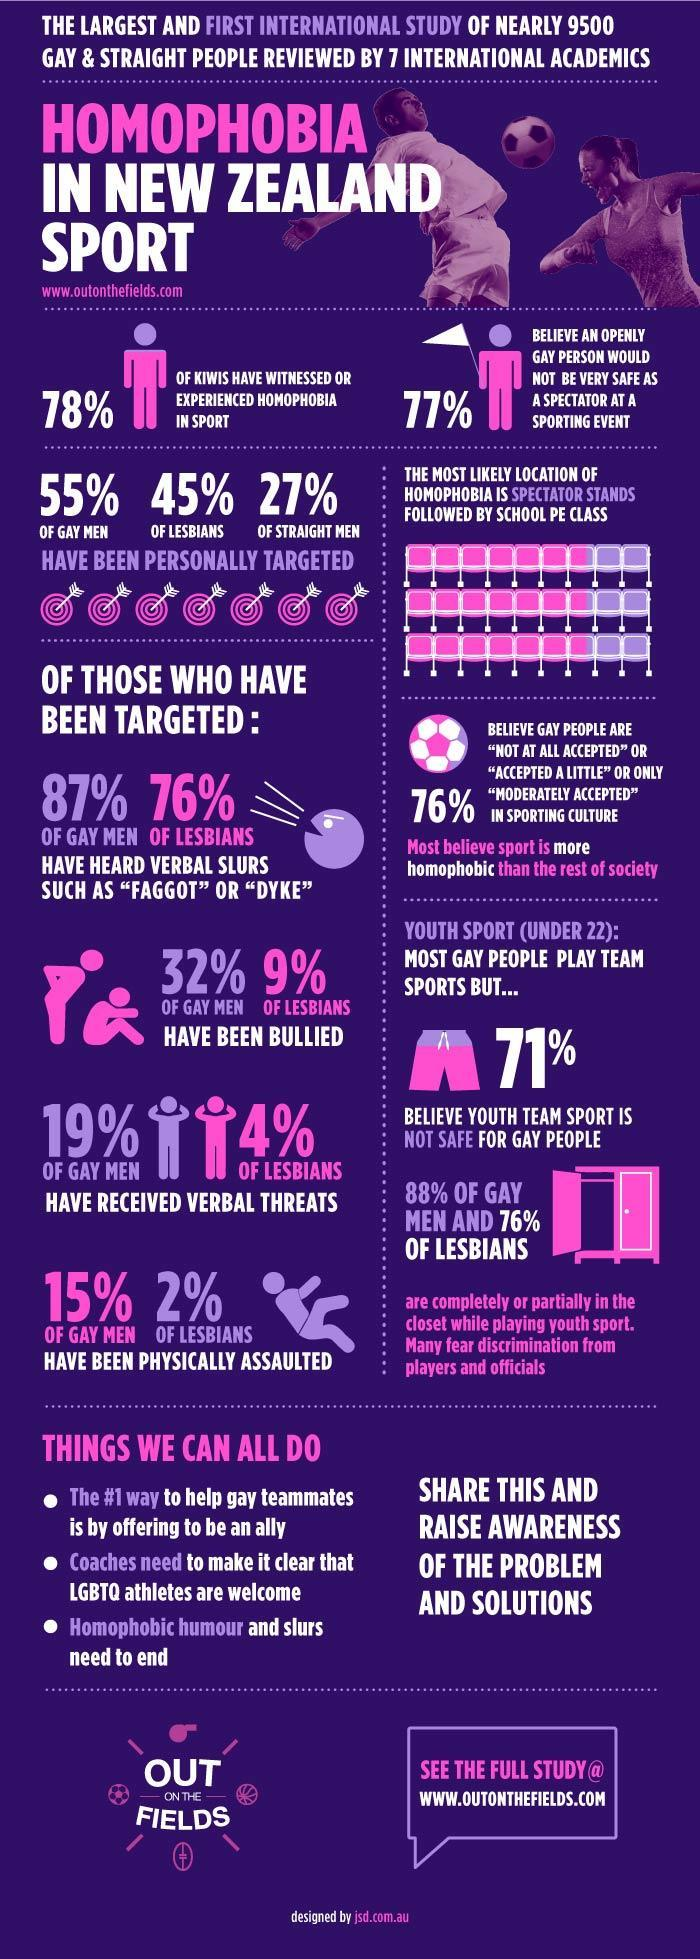Who has been bullied more- gay or lesbian?
Answer the question with a short phrase. GAY MEN 